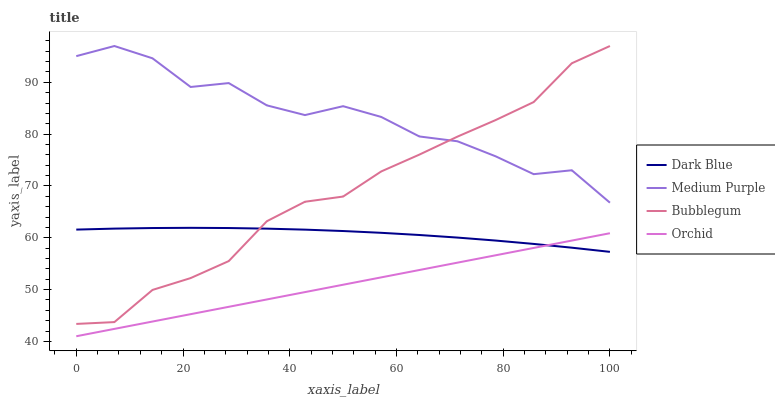Does Orchid have the minimum area under the curve?
Answer yes or no. Yes. Does Medium Purple have the maximum area under the curve?
Answer yes or no. Yes. Does Dark Blue have the minimum area under the curve?
Answer yes or no. No. Does Dark Blue have the maximum area under the curve?
Answer yes or no. No. Is Orchid the smoothest?
Answer yes or no. Yes. Is Medium Purple the roughest?
Answer yes or no. Yes. Is Dark Blue the smoothest?
Answer yes or no. No. Is Dark Blue the roughest?
Answer yes or no. No. Does Dark Blue have the lowest value?
Answer yes or no. No. Does Bubblegum have the highest value?
Answer yes or no. Yes. Does Dark Blue have the highest value?
Answer yes or no. No. Is Dark Blue less than Medium Purple?
Answer yes or no. Yes. Is Medium Purple greater than Dark Blue?
Answer yes or no. Yes. Does Bubblegum intersect Medium Purple?
Answer yes or no. Yes. Is Bubblegum less than Medium Purple?
Answer yes or no. No. Is Bubblegum greater than Medium Purple?
Answer yes or no. No. Does Dark Blue intersect Medium Purple?
Answer yes or no. No. 